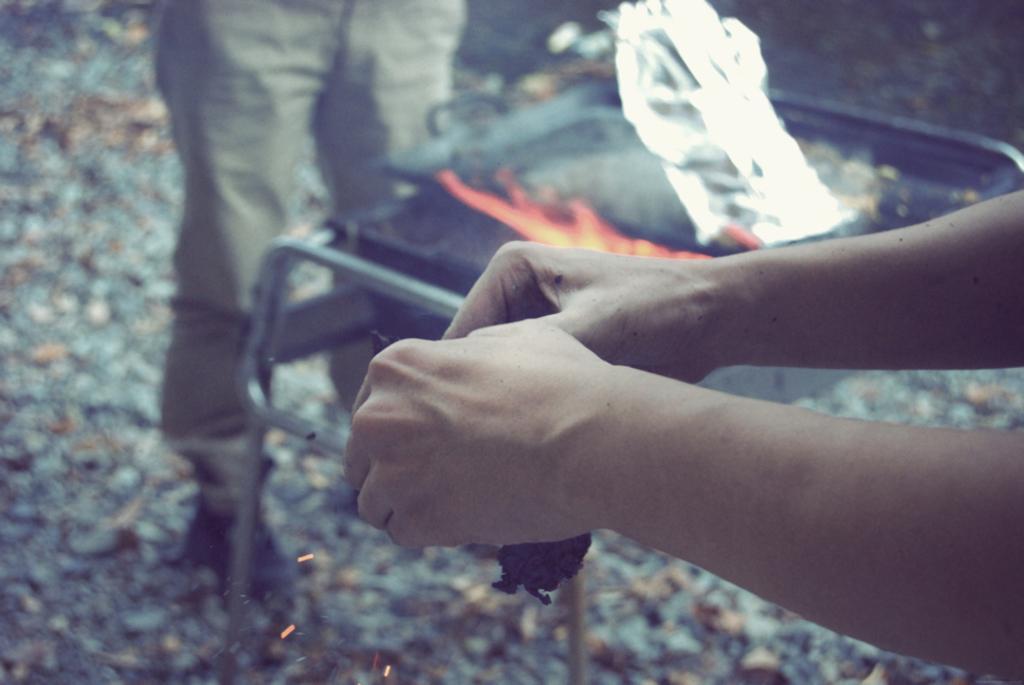Could you give a brief overview of what you see in this image? In the foreground of this image, there are hands of a person holding an object. Behind it, there is a stove like an object, a silver sheet and the legs of a person. 